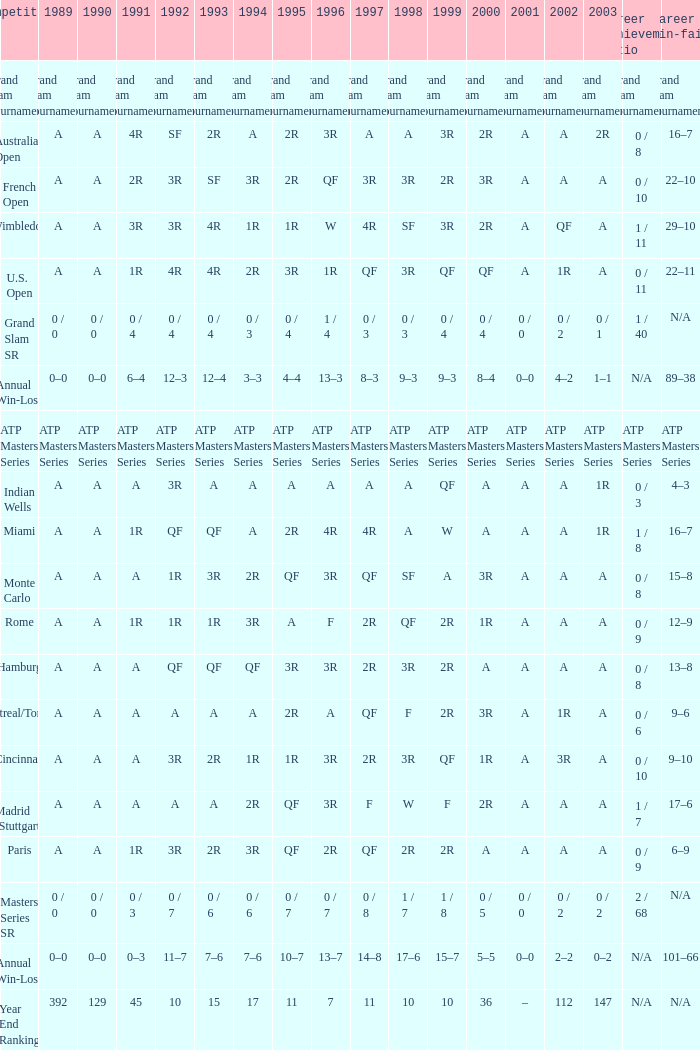What was the value in 1989 with QF in 1997 and A in 1993? A. 